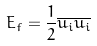<formula> <loc_0><loc_0><loc_500><loc_500>E _ { f } = \frac { 1 } { 2 } \overline { u _ { i } } \overline { u _ { i } }</formula> 